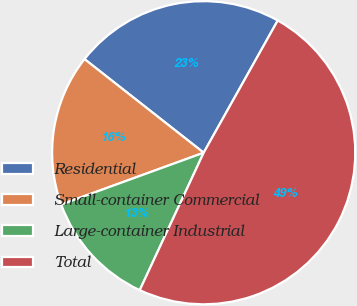Convert chart. <chart><loc_0><loc_0><loc_500><loc_500><pie_chart><fcel>Residential<fcel>Small-container Commercial<fcel>Large-container Industrial<fcel>Total<nl><fcel>22.53%<fcel>16.15%<fcel>12.52%<fcel>48.81%<nl></chart> 